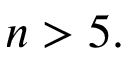Convert formula to latex. <formula><loc_0><loc_0><loc_500><loc_500>n > 5 .</formula> 